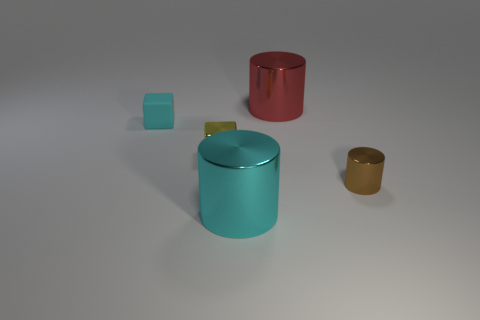Add 3 yellow objects. How many objects exist? 8 Subtract all cylinders. How many objects are left? 2 Subtract 0 red blocks. How many objects are left? 5 Subtract all yellow rubber objects. Subtract all yellow things. How many objects are left? 4 Add 5 small metal cylinders. How many small metal cylinders are left? 6 Add 5 small brown cylinders. How many small brown cylinders exist? 6 